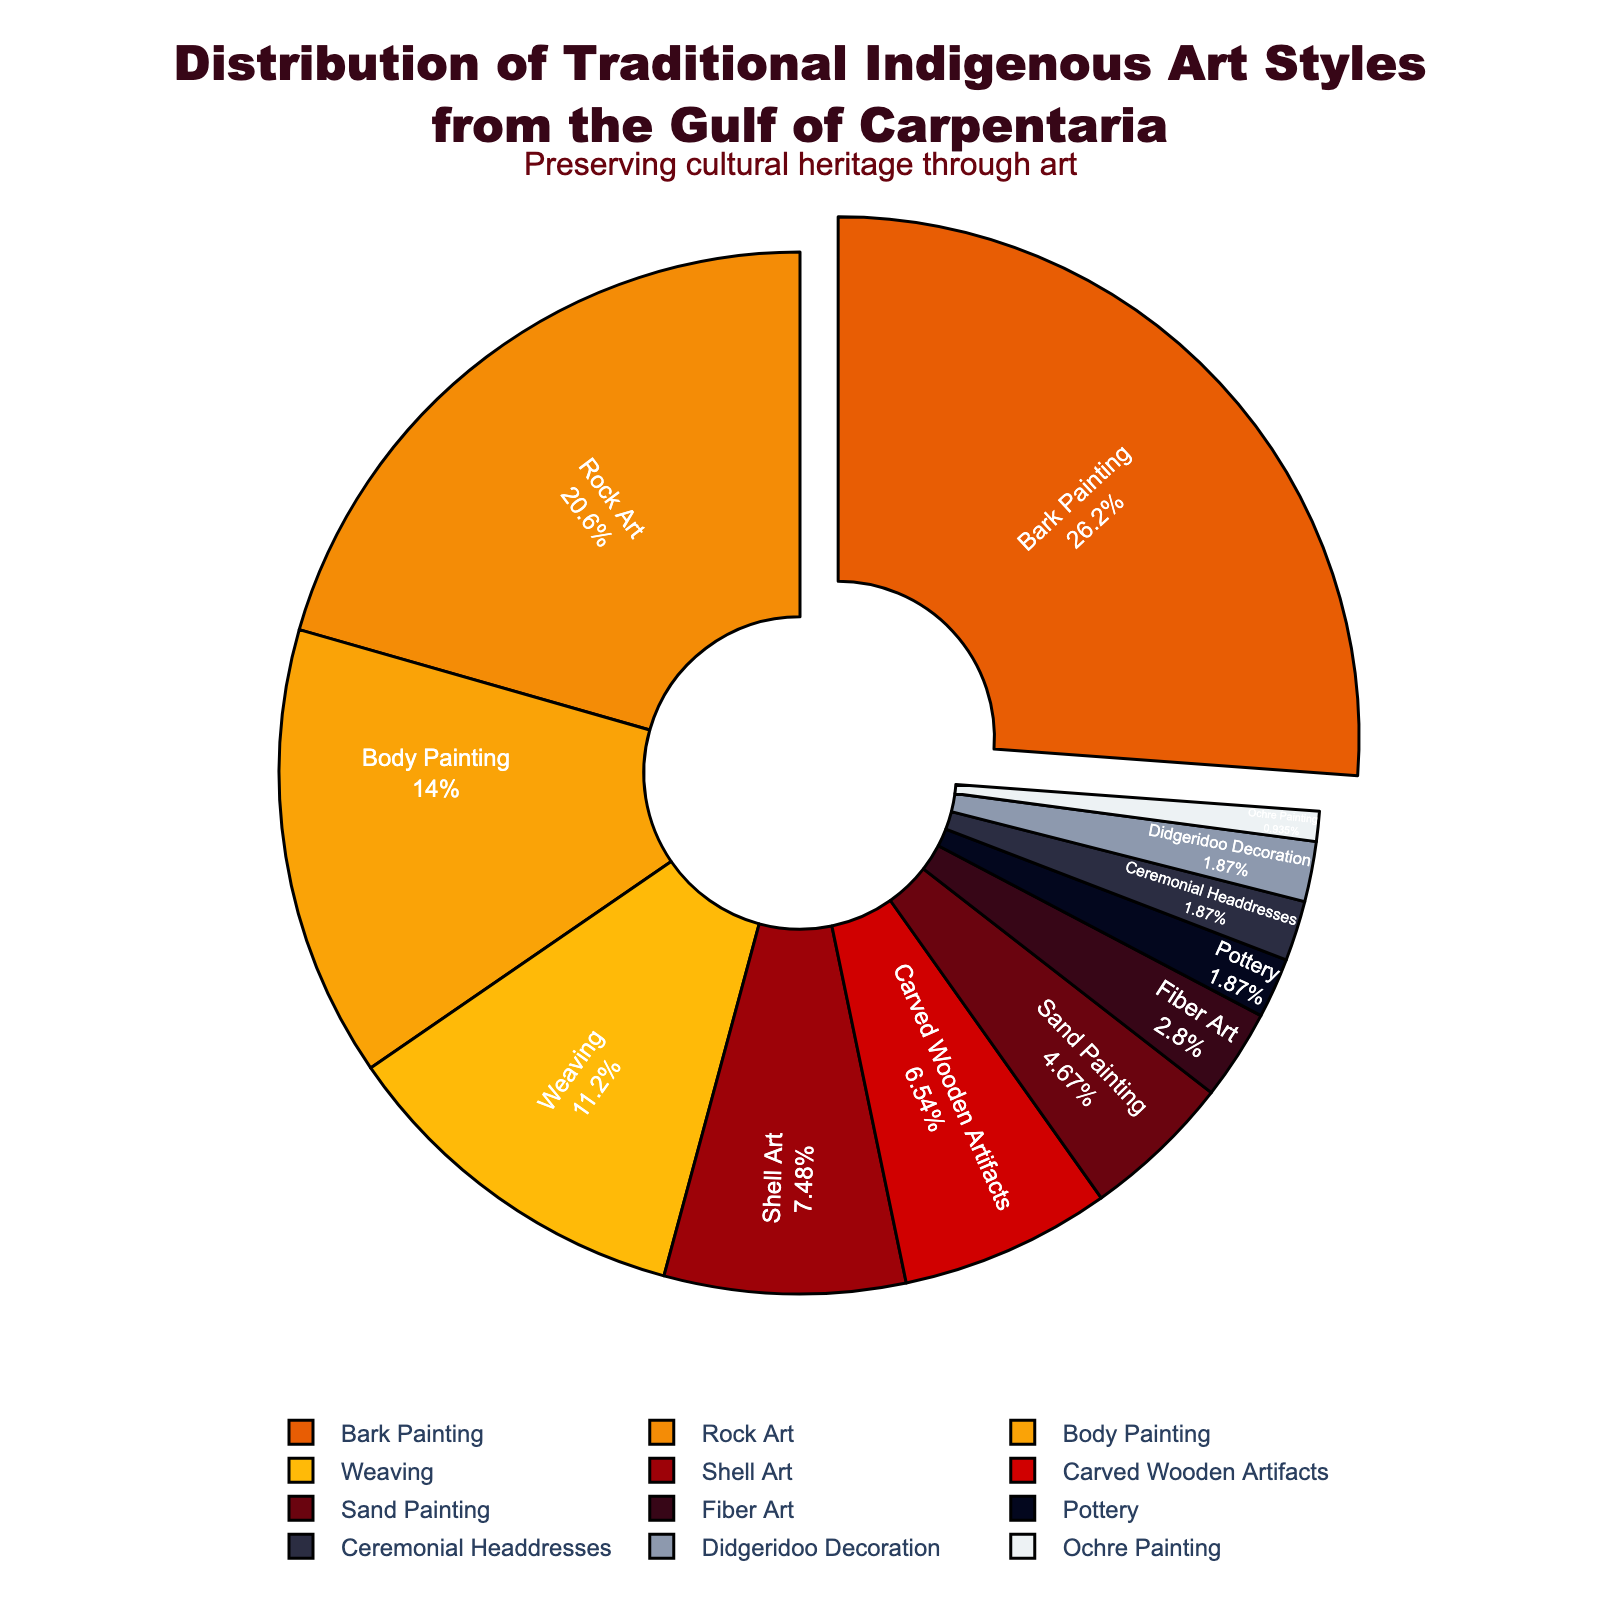Which art style has the highest representation in the Gulf of Carpentaria? We identify the art style with the largest percentage on the pie chart. "Bark Painting" has the highest slice, labeled with 28%.
Answer: Bark Painting How much more frequent is Rock Art compared to Shell Art? Extract the percentages for Rock Art (22%) and Shell Art (8%) from the chart. The difference is calculated as 22% - 8%.
Answer: 14% What is the total percentage of Body Painting, Weaving, and Shell Art combined? Add the percentages of Body Painting (15%), Weaving (12%), and Shell Art (8%). The total is 15% + 12% + 8%.
Answer: 35% Which art style has a percentage close to Pottery? Look at the slices; Pottery is labeled with 2%. Other art styles with 2% are Didgeridoo Decoration and Ceremonial Headdresses.
Answer: Didgeridoo Decoration, Ceremonial Headdresses What is the percentage difference between the least and most represented art styles? Identify the least and most represented art styles: Ochre Painting (1%) and Bark Painting (28%). The difference is calculated as 28% - 1%.
Answer: 27% What percentage of the total is contributed by the three smallest art styles? Sum the percentages of the three smallest slices: Pottery (2%), Ceremonial Headdresses (2%), and Didgeridoo Decoration (2%). Total is 2% + 2% + 2%.
Answer: 6% Which art style, other than Bark Painting, stands out in the chart visually and by percentage? Apart from Bark Painting (28%), the next prominent section is Rock Art at 22%.
Answer: Rock Art What is the combined percentage of art styles that contribute less than 10% individually? Collect and sum the percentages for styles below 10%: Shell Art (8%), Carved Wooden Artifacts (7%), Sand Painting (5%), Fiber Art (3%), Pottery (2%), Ceremonial Headdresses (2%), Didgeridoo Decoration (2%), and Ochre Painting (1%). Total is 30%.
Answer: 30% Which art style has a red-colored slice, and what is its percentage? Identify the slice colored red corresponding to Bark Painting. Its percentage is labeled as 28%.
Answer: Bark Painting, 28% How does the percentage of Carved Wooden Artifacts compare to that of Body Painting? Identify the slices for Carved Wooden Artifacts (7%) and Body Painting (15%). Compare them by calculating the difference, 15% - 7%.
Answer: Body Painting is 8% more 